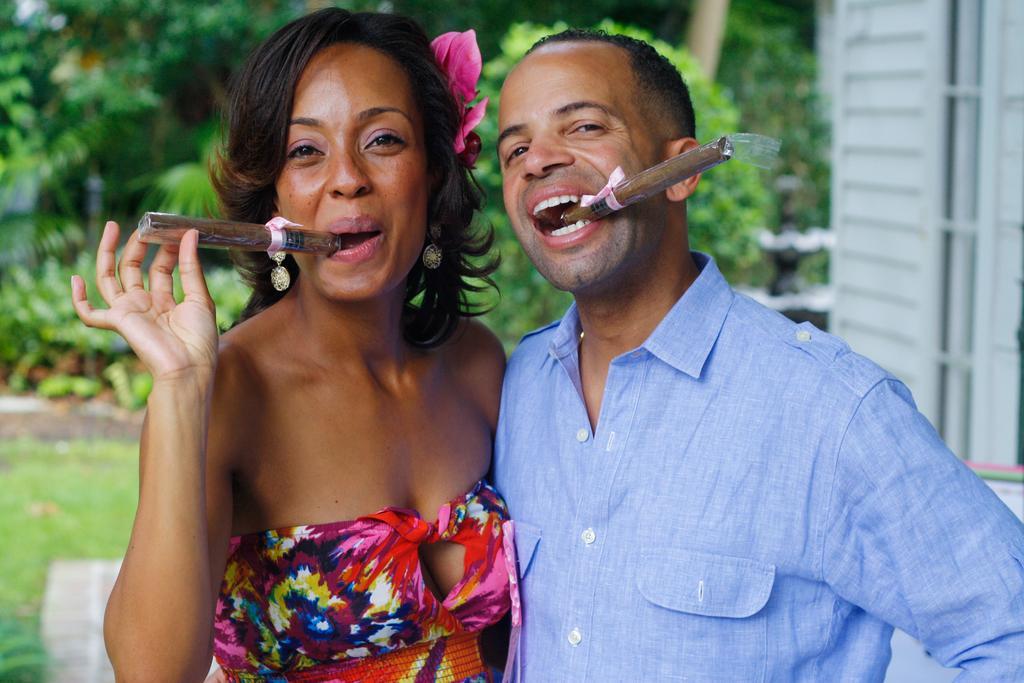Could you give a brief overview of what you see in this image? In this image, there are a few people with some objects in their mouth. We can see the ground covered with grass. We can see some plants and a white colored object on the right. 